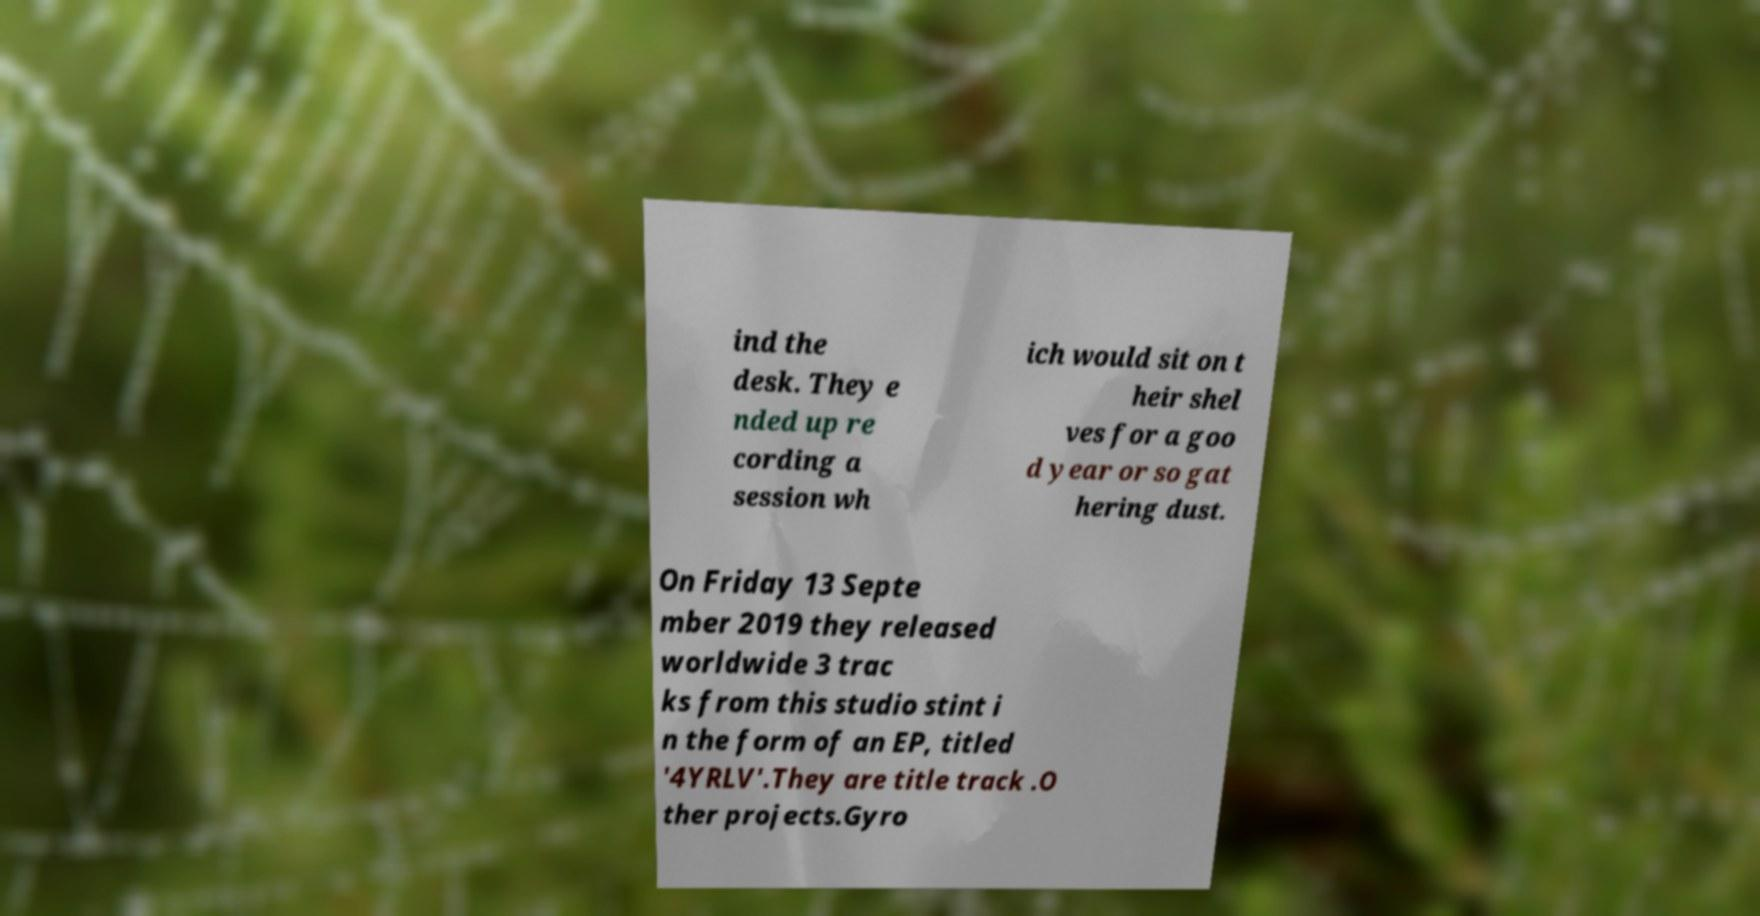Could you extract and type out the text from this image? ind the desk. They e nded up re cording a session wh ich would sit on t heir shel ves for a goo d year or so gat hering dust. On Friday 13 Septe mber 2019 they released worldwide 3 trac ks from this studio stint i n the form of an EP, titled '4YRLV'.They are title track .O ther projects.Gyro 